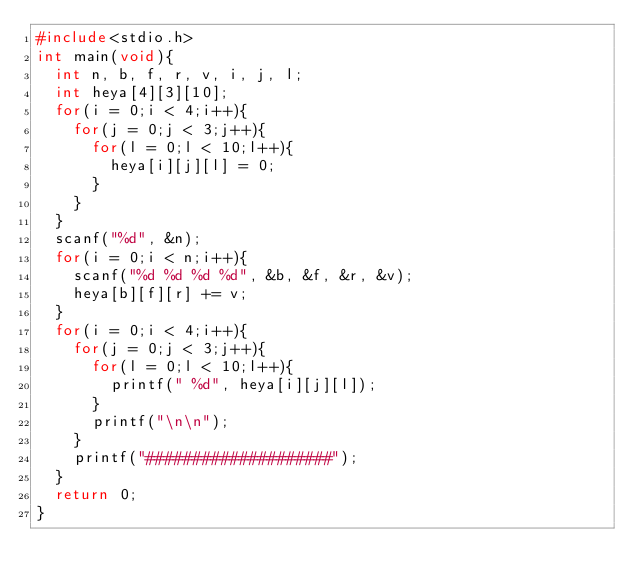Convert code to text. <code><loc_0><loc_0><loc_500><loc_500><_C_>#include<stdio.h>
int main(void){
	int n, b, f, r, v, i, j, l;
	int heya[4][3][10];
	for(i = 0;i < 4;i++){
		for(j = 0;j < 3;j++){
			for(l = 0;l < 10;l++){
				heya[i][j][l] = 0;
			}
		}
	}
	scanf("%d", &n);
	for(i = 0;i < n;i++){
		scanf("%d %d %d %d", &b, &f, &r, &v);
		heya[b][f][r] += v;
	}
	for(i = 0;i < 4;i++){
		for(j = 0;j < 3;j++){
			for(l = 0;l < 10;l++){
				printf(" %d", heya[i][j][l]);
			}
			printf("\n\n");
		}
		printf("####################");
	}
	return 0;
}</code> 